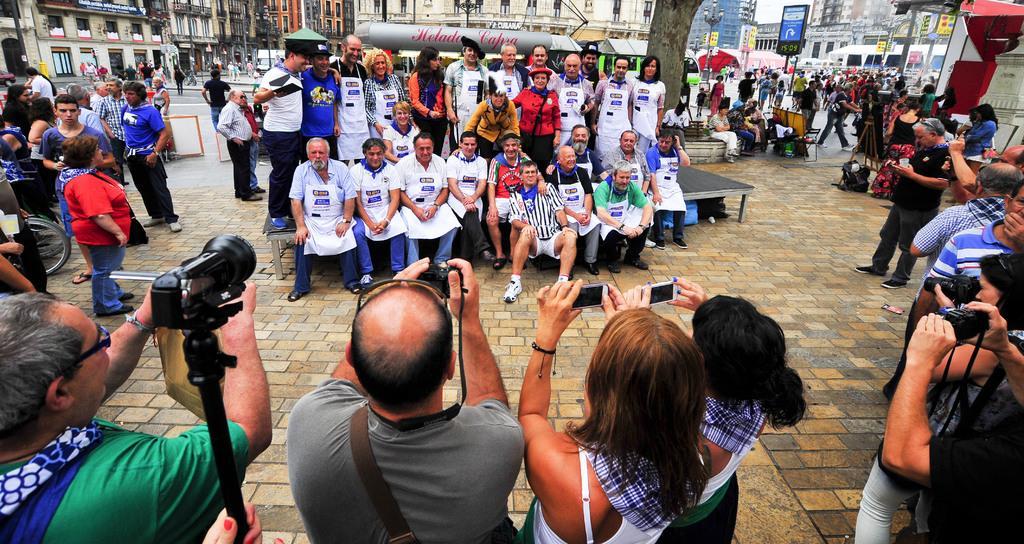In one or two sentences, can you explain what this image depicts? In the image there are many people standing. Few of them are holding cameras in their hands. In front of them there are few people standing and few them are sitting. In the background there are vehicles, buildings, poles with posters and sign boards 